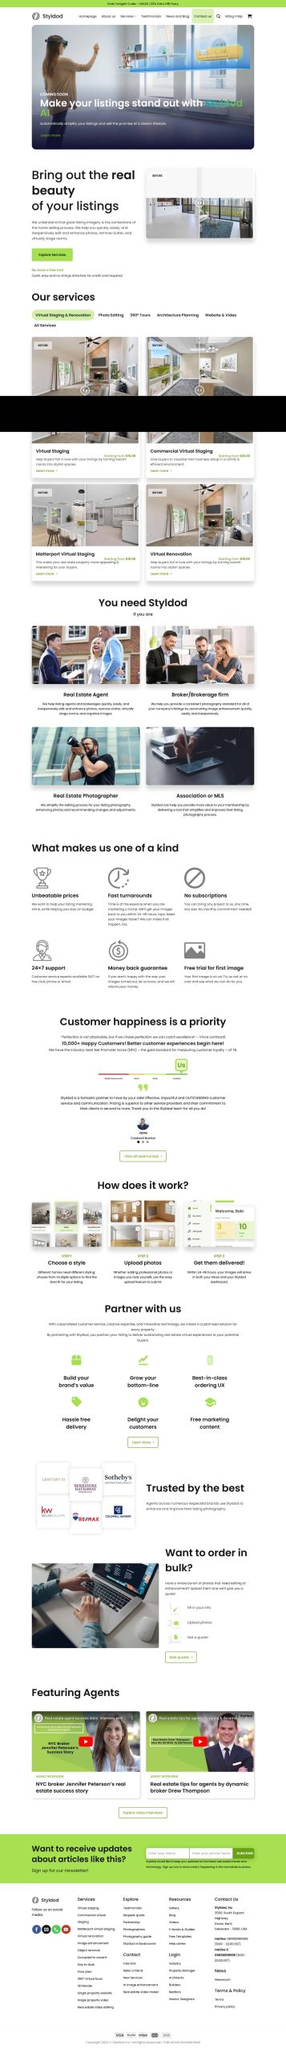Liệt kê 5 ngành nghề, lĩnh vực phù hợp với website này, phân cách các màu sắc bằng dấu phẩy. Chỉ trả về kết quả, phân cách bằng dấy phẩy
 Bất động sản, Môi giới, Nhiếp ảnh bất động sản, Quy hoạch kiến trúc, Thiết kế nội thất 